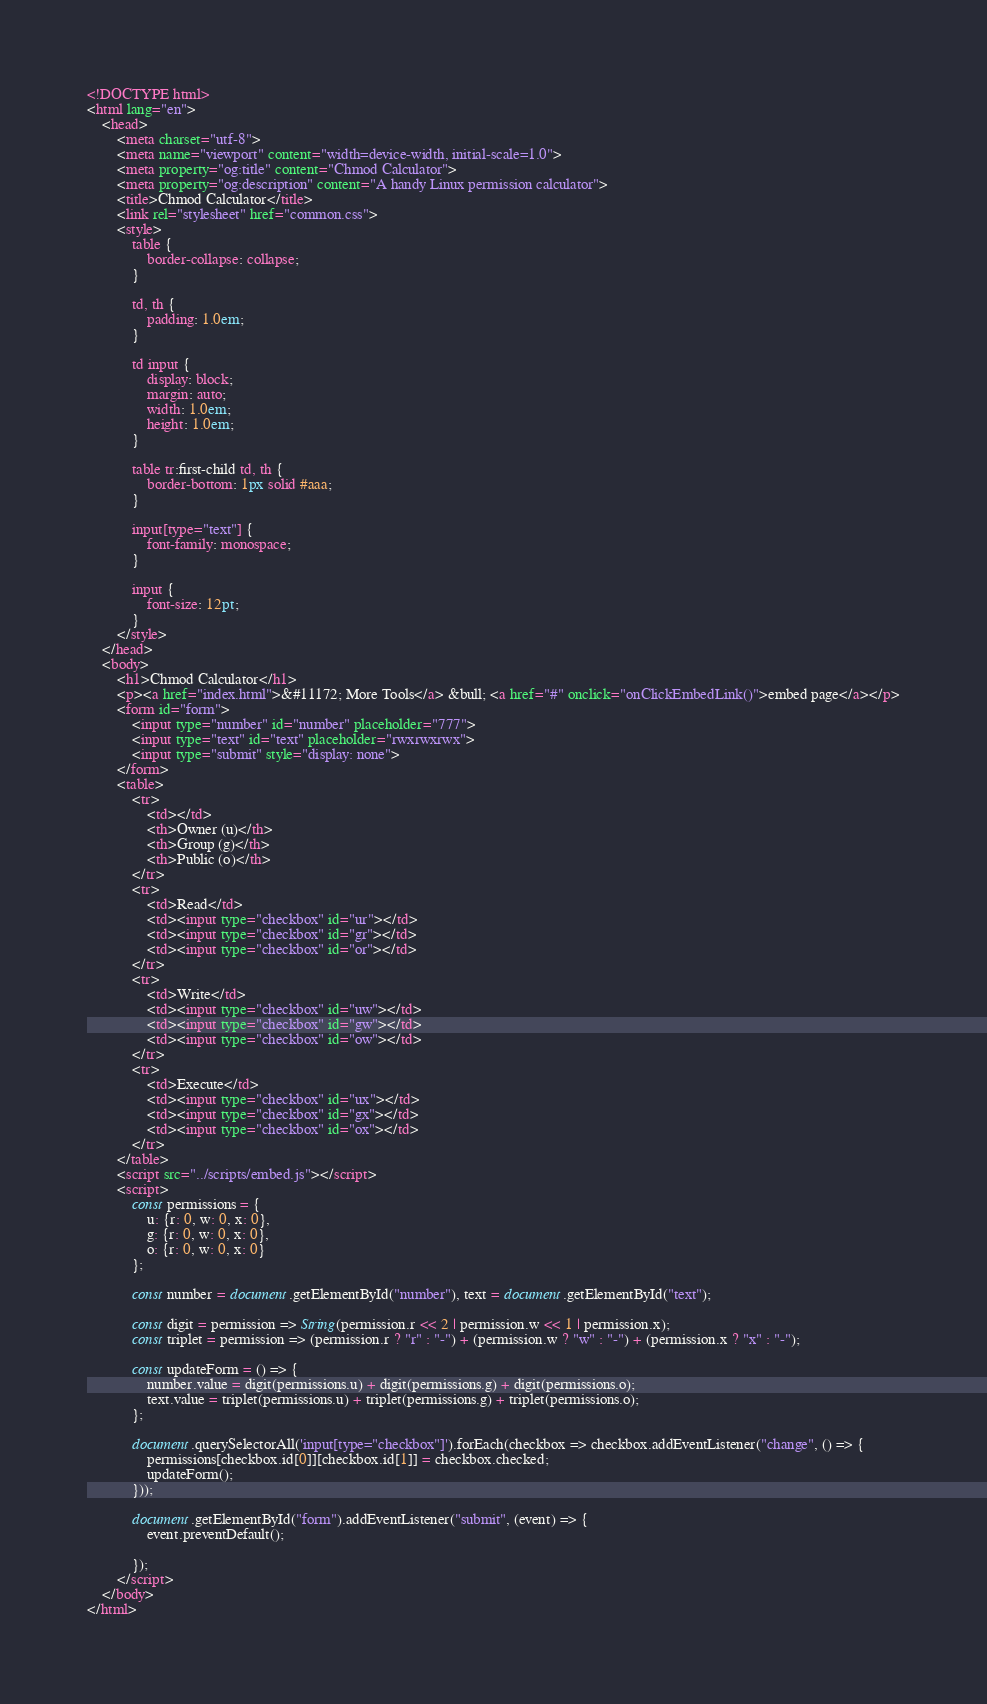Convert code to text. <code><loc_0><loc_0><loc_500><loc_500><_HTML_><!DOCTYPE html>
<html lang="en">
    <head>
        <meta charset="utf-8">
        <meta name="viewport" content="width=device-width, initial-scale=1.0">
        <meta property="og:title" content="Chmod Calculator">
        <meta property="og:description" content="A handy Linux permission calculator">
        <title>Chmod Calculator</title>
        <link rel="stylesheet" href="common.css">
        <style>
            table {
                border-collapse: collapse;
            }

            td, th {
                padding: 1.0em;
            }

            td input {
                display: block;
                margin: auto;
                width: 1.0em;
                height: 1.0em;
            }

            table tr:first-child td, th {
                border-bottom: 1px solid #aaa;
            }

            input[type="text"] {
                font-family: monospace;
            }

            input {
                font-size: 12pt;
            }
        </style>
    </head>
    <body>
        <h1>Chmod Calculator</h1>
        <p><a href="index.html">&#11172; More Tools</a> &bull; <a href="#" onclick="onClickEmbedLink()">embed page</a></p>
        <form id="form">
            <input type="number" id="number" placeholder="777">
            <input type="text" id="text" placeholder="rwxrwxrwx">
            <input type="submit" style="display: none">
        </form>
        <table>
            <tr>
                <td></td>
                <th>Owner (u)</th>
                <th>Group (g)</th>
                <th>Public (o)</th>
            </tr>
            <tr>
                <td>Read</td>
                <td><input type="checkbox" id="ur"></td>
                <td><input type="checkbox" id="gr"></td>
                <td><input type="checkbox" id="or"></td>
            </tr>
            <tr>
                <td>Write</td>
                <td><input type="checkbox" id="uw"></td>
                <td><input type="checkbox" id="gw"></td>
                <td><input type="checkbox" id="ow"></td>
            </tr>
            <tr>
                <td>Execute</td>
                <td><input type="checkbox" id="ux"></td>
                <td><input type="checkbox" id="gx"></td>
                <td><input type="checkbox" id="ox"></td>
            </tr>
        </table>
        <script src="../scripts/embed.js"></script>
        <script>
            const permissions = {
                u: {r: 0, w: 0, x: 0},
                g: {r: 0, w: 0, x: 0},
                o: {r: 0, w: 0, x: 0}
            };

            const number = document.getElementById("number"), text = document.getElementById("text");

            const digit = permission => String(permission.r << 2 | permission.w << 1 | permission.x);
            const triplet = permission => (permission.r ? "r" : "-") + (permission.w ? "w" : "-") + (permission.x ? "x" : "-");

            const updateForm = () => {
                number.value = digit(permissions.u) + digit(permissions.g) + digit(permissions.o);
                text.value = triplet(permissions.u) + triplet(permissions.g) + triplet(permissions.o);
            };

            document.querySelectorAll('input[type="checkbox"]').forEach(checkbox => checkbox.addEventListener("change", () => {
                permissions[checkbox.id[0]][checkbox.id[1]] = checkbox.checked;
                updateForm();
            }));

            document.getElementById("form").addEventListener("submit", (event) => {
                event.preventDefault();
                
            });
        </script>
    </body>
</html></code> 